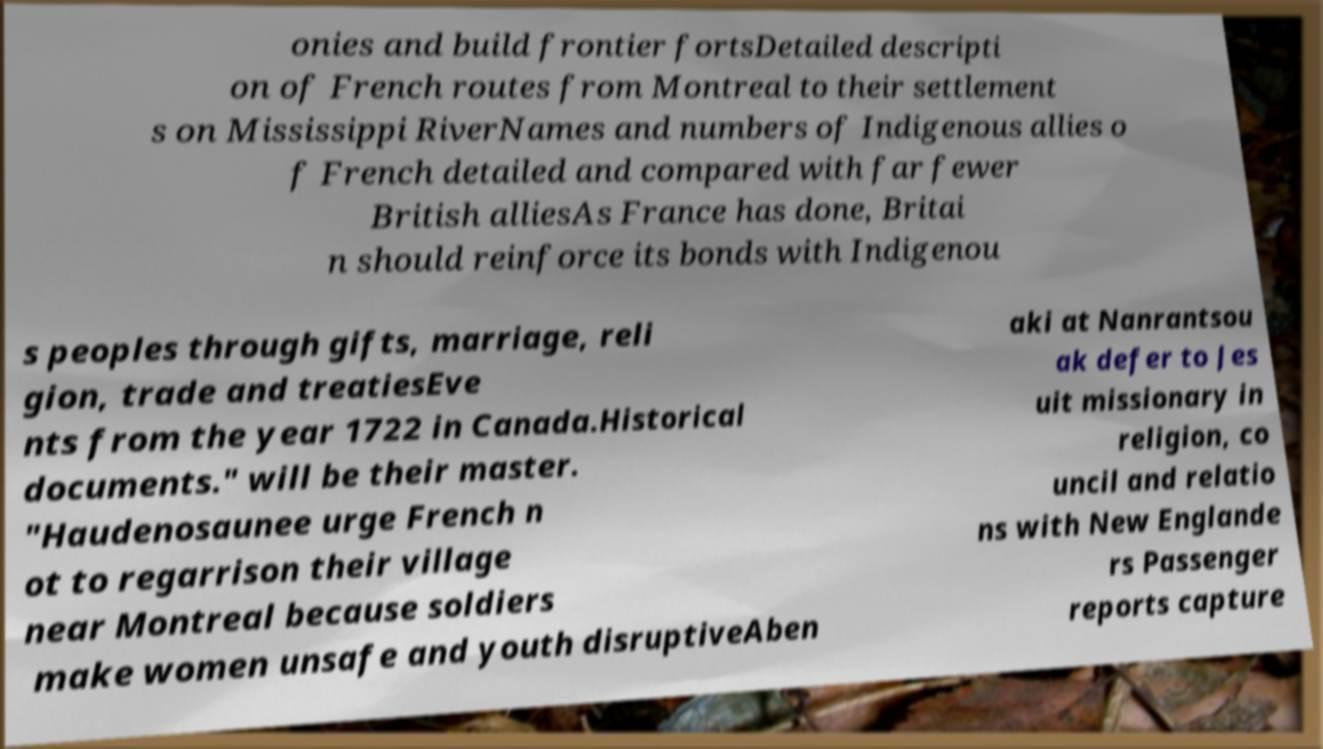There's text embedded in this image that I need extracted. Can you transcribe it verbatim? onies and build frontier fortsDetailed descripti on of French routes from Montreal to their settlement s on Mississippi RiverNames and numbers of Indigenous allies o f French detailed and compared with far fewer British alliesAs France has done, Britai n should reinforce its bonds with Indigenou s peoples through gifts, marriage, reli gion, trade and treatiesEve nts from the year 1722 in Canada.Historical documents." will be their master. "Haudenosaunee urge French n ot to regarrison their village near Montreal because soldiers make women unsafe and youth disruptiveAben aki at Nanrantsou ak defer to Jes uit missionary in religion, co uncil and relatio ns with New Englande rs Passenger reports capture 